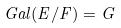<formula> <loc_0><loc_0><loc_500><loc_500>G a l ( E / F ) = G</formula> 